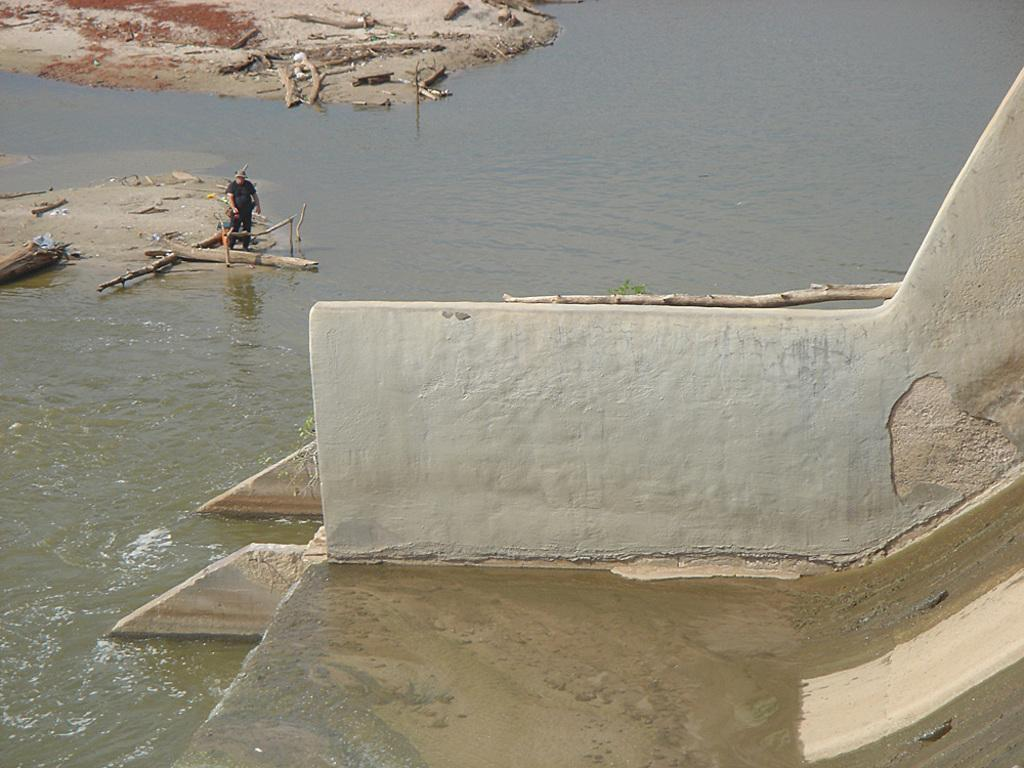What type of playground equipment is in the image? There is a slide in the image. What else can be seen in the background of the image? There is a wall in the image. What is near the wall in the image? Water is visible beside the wall. Can you describe the person in the image? There is a person standing in the image. What objects are present on the ground in the image? There are sticks present in the image. What type of cap is the person wearing in the image? There is no cap visible in the image; the person is not wearing one. 